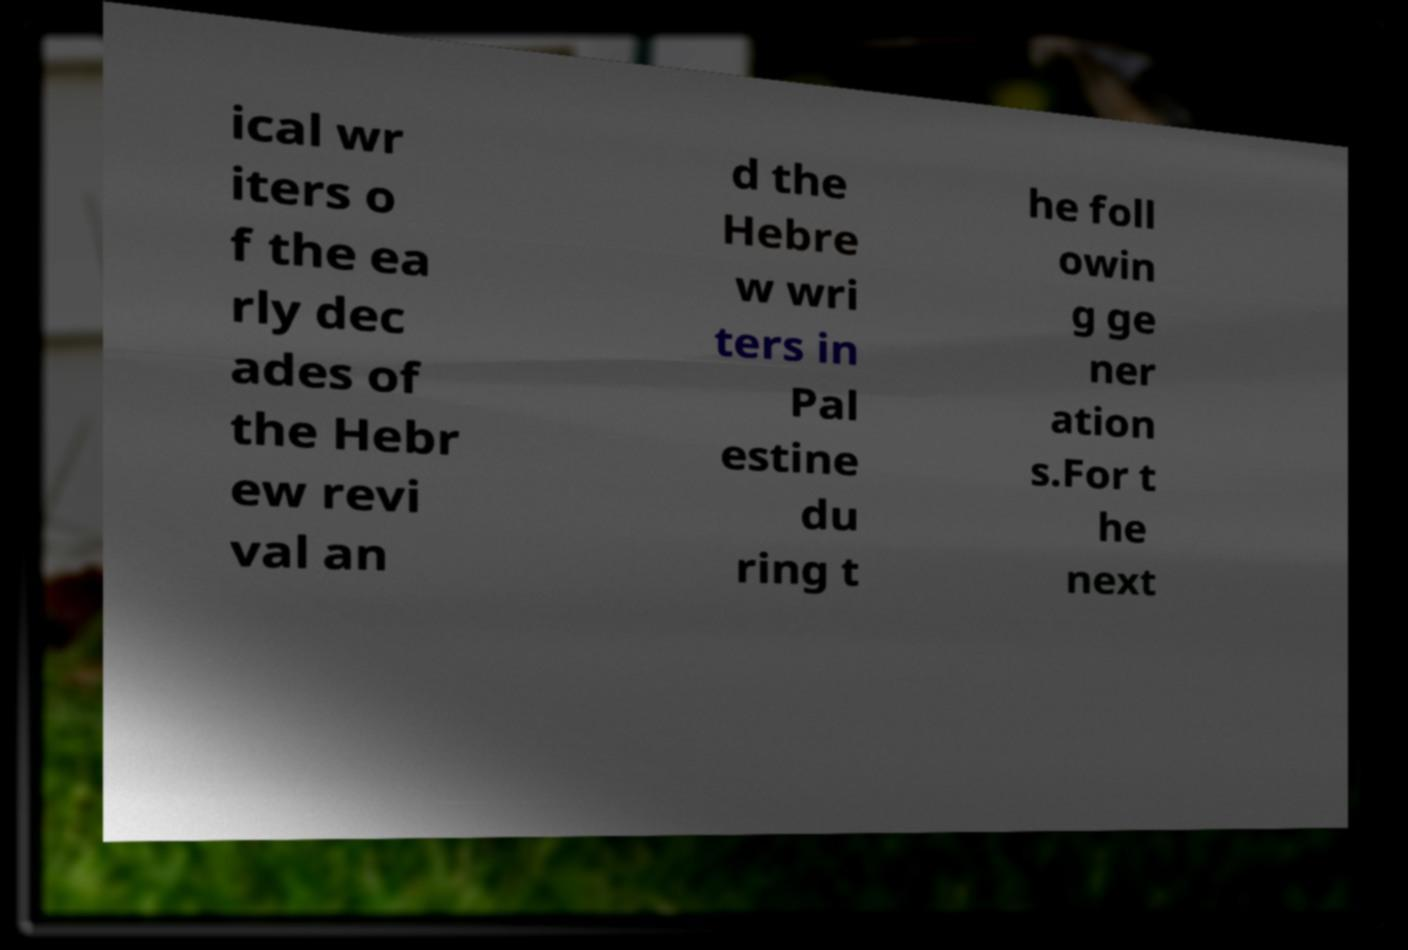Please read and relay the text visible in this image. What does it say? ical wr iters o f the ea rly dec ades of the Hebr ew revi val an d the Hebre w wri ters in Pal estine du ring t he foll owin g ge ner ation s.For t he next 